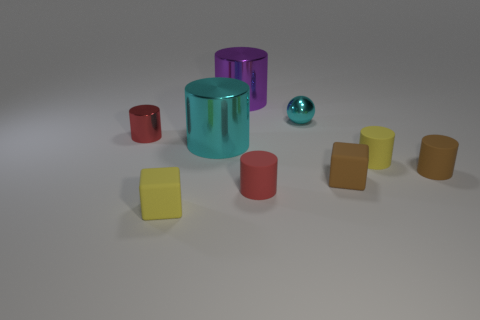Is there any pattern or order to how the objects are arranged? At a glance, the objects seem to be arranged randomly. However, there's a subtle grouping by shape with the cylinders clustered on the left side and the cubes more to the right. The tiny metallic sphere is an outlier, positioned in front of the large cyan cylinder, adding a touch of asymmetry to the scene. 